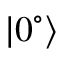Convert formula to latex. <formula><loc_0><loc_0><loc_500><loc_500>| 0 ^ { \circ } \rangle</formula> 